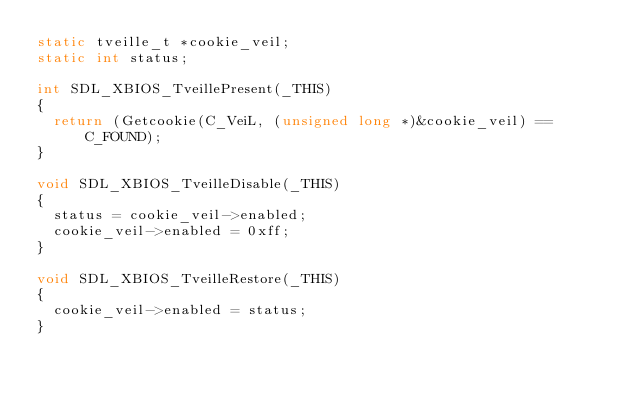Convert code to text. <code><loc_0><loc_0><loc_500><loc_500><_C_>static tveille_t *cookie_veil;
static int status;

int SDL_XBIOS_TveillePresent(_THIS)
{
	return (Getcookie(C_VeiL, (unsigned long *)&cookie_veil) == C_FOUND);
}

void SDL_XBIOS_TveilleDisable(_THIS)
{
	status = cookie_veil->enabled;
	cookie_veil->enabled = 0xff;
}

void SDL_XBIOS_TveilleRestore(_THIS)
{
	cookie_veil->enabled = status;
}
</code> 